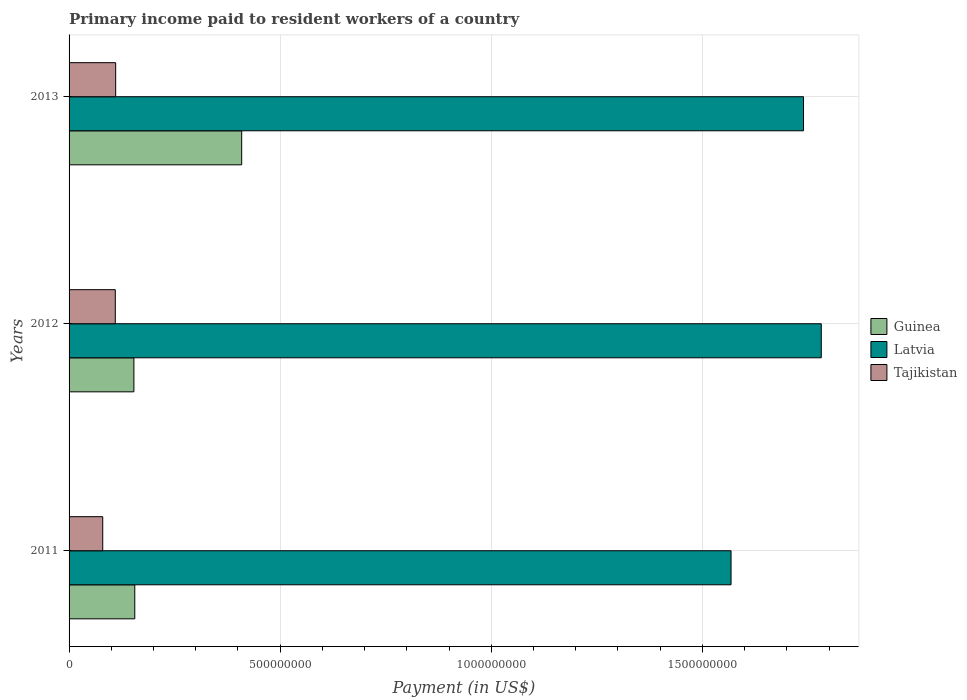Are the number of bars per tick equal to the number of legend labels?
Your response must be concise. Yes. How many bars are there on the 3rd tick from the top?
Ensure brevity in your answer.  3. What is the label of the 1st group of bars from the top?
Your response must be concise. 2013. What is the amount paid to workers in Guinea in 2013?
Make the answer very short. 4.09e+08. Across all years, what is the maximum amount paid to workers in Tajikistan?
Offer a very short reply. 1.10e+08. Across all years, what is the minimum amount paid to workers in Guinea?
Provide a short and direct response. 1.54e+08. What is the total amount paid to workers in Guinea in the graph?
Ensure brevity in your answer.  7.18e+08. What is the difference between the amount paid to workers in Tajikistan in 2012 and that in 2013?
Give a very brief answer. -9.04e+05. What is the difference between the amount paid to workers in Latvia in 2011 and the amount paid to workers in Guinea in 2013?
Your response must be concise. 1.16e+09. What is the average amount paid to workers in Guinea per year?
Your answer should be very brief. 2.39e+08. In the year 2011, what is the difference between the amount paid to workers in Latvia and amount paid to workers in Tajikistan?
Your answer should be compact. 1.49e+09. What is the ratio of the amount paid to workers in Latvia in 2011 to that in 2013?
Your answer should be compact. 0.9. What is the difference between the highest and the second highest amount paid to workers in Latvia?
Keep it short and to the point. 4.21e+07. What is the difference between the highest and the lowest amount paid to workers in Guinea?
Your response must be concise. 2.55e+08. What does the 1st bar from the top in 2013 represents?
Your answer should be very brief. Tajikistan. What does the 3rd bar from the bottom in 2012 represents?
Offer a terse response. Tajikistan. How many bars are there?
Offer a very short reply. 9. What is the difference between two consecutive major ticks on the X-axis?
Ensure brevity in your answer.  5.00e+08. Are the values on the major ticks of X-axis written in scientific E-notation?
Make the answer very short. No. Does the graph contain any zero values?
Ensure brevity in your answer.  No. Where does the legend appear in the graph?
Your answer should be very brief. Center right. How many legend labels are there?
Provide a short and direct response. 3. How are the legend labels stacked?
Give a very brief answer. Vertical. What is the title of the graph?
Provide a succinct answer. Primary income paid to resident workers of a country. Does "Monaco" appear as one of the legend labels in the graph?
Make the answer very short. No. What is the label or title of the X-axis?
Your answer should be compact. Payment (in US$). What is the label or title of the Y-axis?
Offer a very short reply. Years. What is the Payment (in US$) in Guinea in 2011?
Offer a terse response. 1.56e+08. What is the Payment (in US$) of Latvia in 2011?
Give a very brief answer. 1.57e+09. What is the Payment (in US$) in Tajikistan in 2011?
Give a very brief answer. 7.97e+07. What is the Payment (in US$) in Guinea in 2012?
Your answer should be very brief. 1.54e+08. What is the Payment (in US$) in Latvia in 2012?
Ensure brevity in your answer.  1.78e+09. What is the Payment (in US$) of Tajikistan in 2012?
Offer a very short reply. 1.09e+08. What is the Payment (in US$) in Guinea in 2013?
Provide a succinct answer. 4.09e+08. What is the Payment (in US$) in Latvia in 2013?
Keep it short and to the point. 1.74e+09. What is the Payment (in US$) of Tajikistan in 2013?
Ensure brevity in your answer.  1.10e+08. Across all years, what is the maximum Payment (in US$) in Guinea?
Keep it short and to the point. 4.09e+08. Across all years, what is the maximum Payment (in US$) of Latvia?
Your answer should be very brief. 1.78e+09. Across all years, what is the maximum Payment (in US$) in Tajikistan?
Your response must be concise. 1.10e+08. Across all years, what is the minimum Payment (in US$) in Guinea?
Your answer should be compact. 1.54e+08. Across all years, what is the minimum Payment (in US$) in Latvia?
Your response must be concise. 1.57e+09. Across all years, what is the minimum Payment (in US$) of Tajikistan?
Provide a short and direct response. 7.97e+07. What is the total Payment (in US$) of Guinea in the graph?
Your answer should be very brief. 7.18e+08. What is the total Payment (in US$) of Latvia in the graph?
Offer a very short reply. 5.09e+09. What is the total Payment (in US$) in Tajikistan in the graph?
Your response must be concise. 3.00e+08. What is the difference between the Payment (in US$) in Guinea in 2011 and that in 2012?
Keep it short and to the point. 2.11e+06. What is the difference between the Payment (in US$) in Latvia in 2011 and that in 2012?
Keep it short and to the point. -2.14e+08. What is the difference between the Payment (in US$) of Tajikistan in 2011 and that in 2012?
Offer a terse response. -2.97e+07. What is the difference between the Payment (in US$) in Guinea in 2011 and that in 2013?
Keep it short and to the point. -2.53e+08. What is the difference between the Payment (in US$) of Latvia in 2011 and that in 2013?
Your response must be concise. -1.72e+08. What is the difference between the Payment (in US$) of Tajikistan in 2011 and that in 2013?
Your answer should be compact. -3.06e+07. What is the difference between the Payment (in US$) of Guinea in 2012 and that in 2013?
Provide a succinct answer. -2.55e+08. What is the difference between the Payment (in US$) in Latvia in 2012 and that in 2013?
Your answer should be compact. 4.21e+07. What is the difference between the Payment (in US$) of Tajikistan in 2012 and that in 2013?
Give a very brief answer. -9.04e+05. What is the difference between the Payment (in US$) of Guinea in 2011 and the Payment (in US$) of Latvia in 2012?
Your answer should be very brief. -1.63e+09. What is the difference between the Payment (in US$) in Guinea in 2011 and the Payment (in US$) in Tajikistan in 2012?
Give a very brief answer. 4.62e+07. What is the difference between the Payment (in US$) in Latvia in 2011 and the Payment (in US$) in Tajikistan in 2012?
Make the answer very short. 1.46e+09. What is the difference between the Payment (in US$) in Guinea in 2011 and the Payment (in US$) in Latvia in 2013?
Keep it short and to the point. -1.58e+09. What is the difference between the Payment (in US$) of Guinea in 2011 and the Payment (in US$) of Tajikistan in 2013?
Provide a succinct answer. 4.53e+07. What is the difference between the Payment (in US$) of Latvia in 2011 and the Payment (in US$) of Tajikistan in 2013?
Offer a very short reply. 1.46e+09. What is the difference between the Payment (in US$) of Guinea in 2012 and the Payment (in US$) of Latvia in 2013?
Keep it short and to the point. -1.59e+09. What is the difference between the Payment (in US$) of Guinea in 2012 and the Payment (in US$) of Tajikistan in 2013?
Your response must be concise. 4.32e+07. What is the difference between the Payment (in US$) of Latvia in 2012 and the Payment (in US$) of Tajikistan in 2013?
Ensure brevity in your answer.  1.67e+09. What is the average Payment (in US$) of Guinea per year?
Give a very brief answer. 2.39e+08. What is the average Payment (in US$) of Latvia per year?
Keep it short and to the point. 1.70e+09. What is the average Payment (in US$) in Tajikistan per year?
Ensure brevity in your answer.  9.98e+07. In the year 2011, what is the difference between the Payment (in US$) in Guinea and Payment (in US$) in Latvia?
Your answer should be compact. -1.41e+09. In the year 2011, what is the difference between the Payment (in US$) in Guinea and Payment (in US$) in Tajikistan?
Offer a terse response. 7.59e+07. In the year 2011, what is the difference between the Payment (in US$) of Latvia and Payment (in US$) of Tajikistan?
Keep it short and to the point. 1.49e+09. In the year 2012, what is the difference between the Payment (in US$) of Guinea and Payment (in US$) of Latvia?
Keep it short and to the point. -1.63e+09. In the year 2012, what is the difference between the Payment (in US$) of Guinea and Payment (in US$) of Tajikistan?
Your answer should be compact. 4.41e+07. In the year 2012, what is the difference between the Payment (in US$) in Latvia and Payment (in US$) in Tajikistan?
Provide a short and direct response. 1.67e+09. In the year 2013, what is the difference between the Payment (in US$) in Guinea and Payment (in US$) in Latvia?
Offer a terse response. -1.33e+09. In the year 2013, what is the difference between the Payment (in US$) of Guinea and Payment (in US$) of Tajikistan?
Ensure brevity in your answer.  2.98e+08. In the year 2013, what is the difference between the Payment (in US$) of Latvia and Payment (in US$) of Tajikistan?
Provide a succinct answer. 1.63e+09. What is the ratio of the Payment (in US$) of Guinea in 2011 to that in 2012?
Offer a terse response. 1.01. What is the ratio of the Payment (in US$) of Latvia in 2011 to that in 2012?
Provide a succinct answer. 0.88. What is the ratio of the Payment (in US$) in Tajikistan in 2011 to that in 2012?
Make the answer very short. 0.73. What is the ratio of the Payment (in US$) of Guinea in 2011 to that in 2013?
Offer a very short reply. 0.38. What is the ratio of the Payment (in US$) in Latvia in 2011 to that in 2013?
Your response must be concise. 0.9. What is the ratio of the Payment (in US$) of Tajikistan in 2011 to that in 2013?
Make the answer very short. 0.72. What is the ratio of the Payment (in US$) of Guinea in 2012 to that in 2013?
Provide a short and direct response. 0.38. What is the ratio of the Payment (in US$) in Latvia in 2012 to that in 2013?
Your response must be concise. 1.02. What is the difference between the highest and the second highest Payment (in US$) in Guinea?
Keep it short and to the point. 2.53e+08. What is the difference between the highest and the second highest Payment (in US$) of Latvia?
Make the answer very short. 4.21e+07. What is the difference between the highest and the second highest Payment (in US$) of Tajikistan?
Give a very brief answer. 9.04e+05. What is the difference between the highest and the lowest Payment (in US$) in Guinea?
Ensure brevity in your answer.  2.55e+08. What is the difference between the highest and the lowest Payment (in US$) of Latvia?
Ensure brevity in your answer.  2.14e+08. What is the difference between the highest and the lowest Payment (in US$) in Tajikistan?
Ensure brevity in your answer.  3.06e+07. 